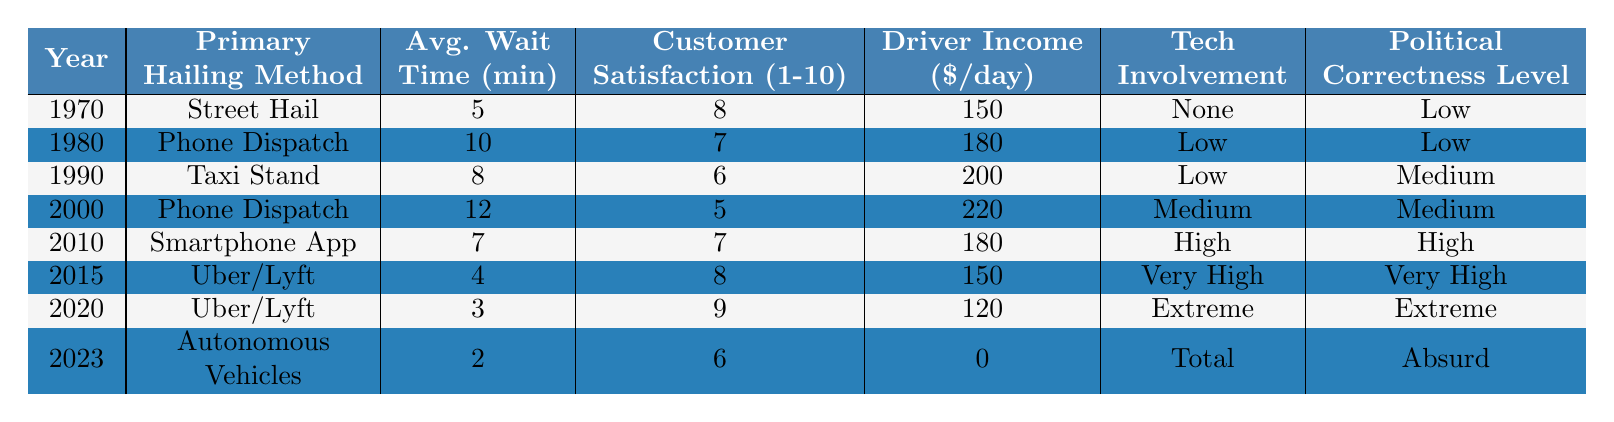What was the primary hailing method in 1990? The table lists the primary hailing method for each year. In 1990, it is stated as "Taxi Stand."
Answer: Taxi Stand What is the average wait time for hailing a taxi in 2020? The table indicates the average wait time for each year, and for 2020, it is recorded as 3 minutes.
Answer: 3 minutes What year had the highest driver income and what was that income? By reviewing the driver income column, the highest income is found in 2000, which is $220.
Answer: $220 in 2000 Was customer satisfaction higher in 1980 than in 1990? In the table, the customer satisfaction score for 1980 is 7, while for 1990 it is 6. Since 7 is more than 6, the satisfaction was indeed higher in 1980.
Answer: Yes What was the increase in average wait time from 1970 to 2000? In 1970, the average wait time was 5 minutes and in 2000 it was 12 minutes. The increase is calculated as 12 - 5 = 7 minutes.
Answer: 7 minutes Is there a trend of increasing customer satisfaction from 2000 to 2020? In 2000, customer satisfaction was 5, and in 2020, it rose to 9. This shows an increase, indicating a trend of higher satisfaction.
Answer: Yes What is the difference in average wait time between 2015 and 2023? The average wait time in 2015 is 4 minutes and in 2023 it is 2 minutes. The difference is calculated as 4 - 2 = 2 minutes.
Answer: 2 minutes What can be inferred about the tech involvement level as hailing methods progressed from 1970 to 2023? Reviewing the table, tech involvement started as None in 1970 and escalated to Total by 2023, which indicates a significant increase in technology's role in taxi hailing over the years.
Answer: Increased significantly What is the overall political correctness level in the year 2023? Looking at the table, it states the political correctness level for 2023 is "Absurd."
Answer: Absurd What was the average driver income for the years 2010, 2015, and 2020? The incomes for these years are $180 (2010), $150 (2015), and $120 (2020). Adding these gives 180 + 150 + 120 = 450, and dividing by 3 (the number of years) gives an average of 450/3 = 150.
Answer: $150 